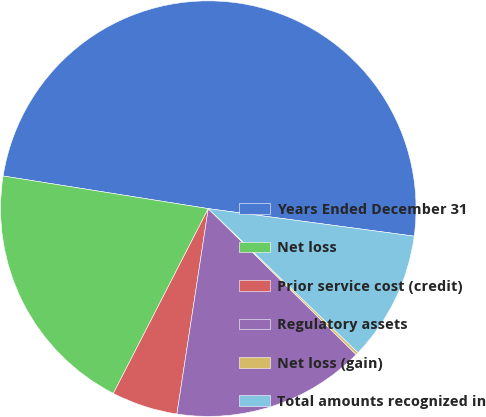Convert chart to OTSL. <chart><loc_0><loc_0><loc_500><loc_500><pie_chart><fcel>Years Ended December 31<fcel>Net loss<fcel>Prior service cost (credit)<fcel>Regulatory assets<fcel>Net loss (gain)<fcel>Total amounts recognized in<nl><fcel>49.61%<fcel>19.96%<fcel>5.14%<fcel>15.02%<fcel>0.2%<fcel>10.08%<nl></chart> 